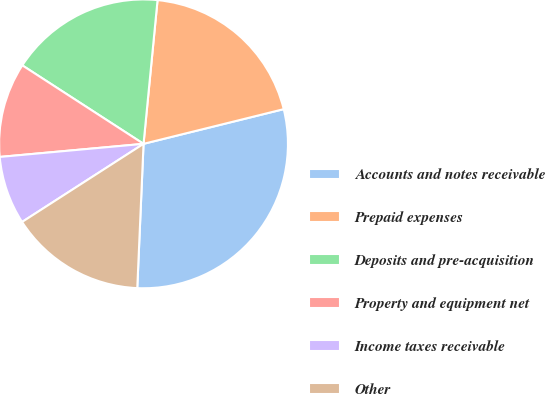Convert chart. <chart><loc_0><loc_0><loc_500><loc_500><pie_chart><fcel>Accounts and notes receivable<fcel>Prepaid expenses<fcel>Deposits and pre-acquisition<fcel>Property and equipment net<fcel>Income taxes receivable<fcel>Other<nl><fcel>29.55%<fcel>19.59%<fcel>17.4%<fcel>10.59%<fcel>7.65%<fcel>15.21%<nl></chart> 